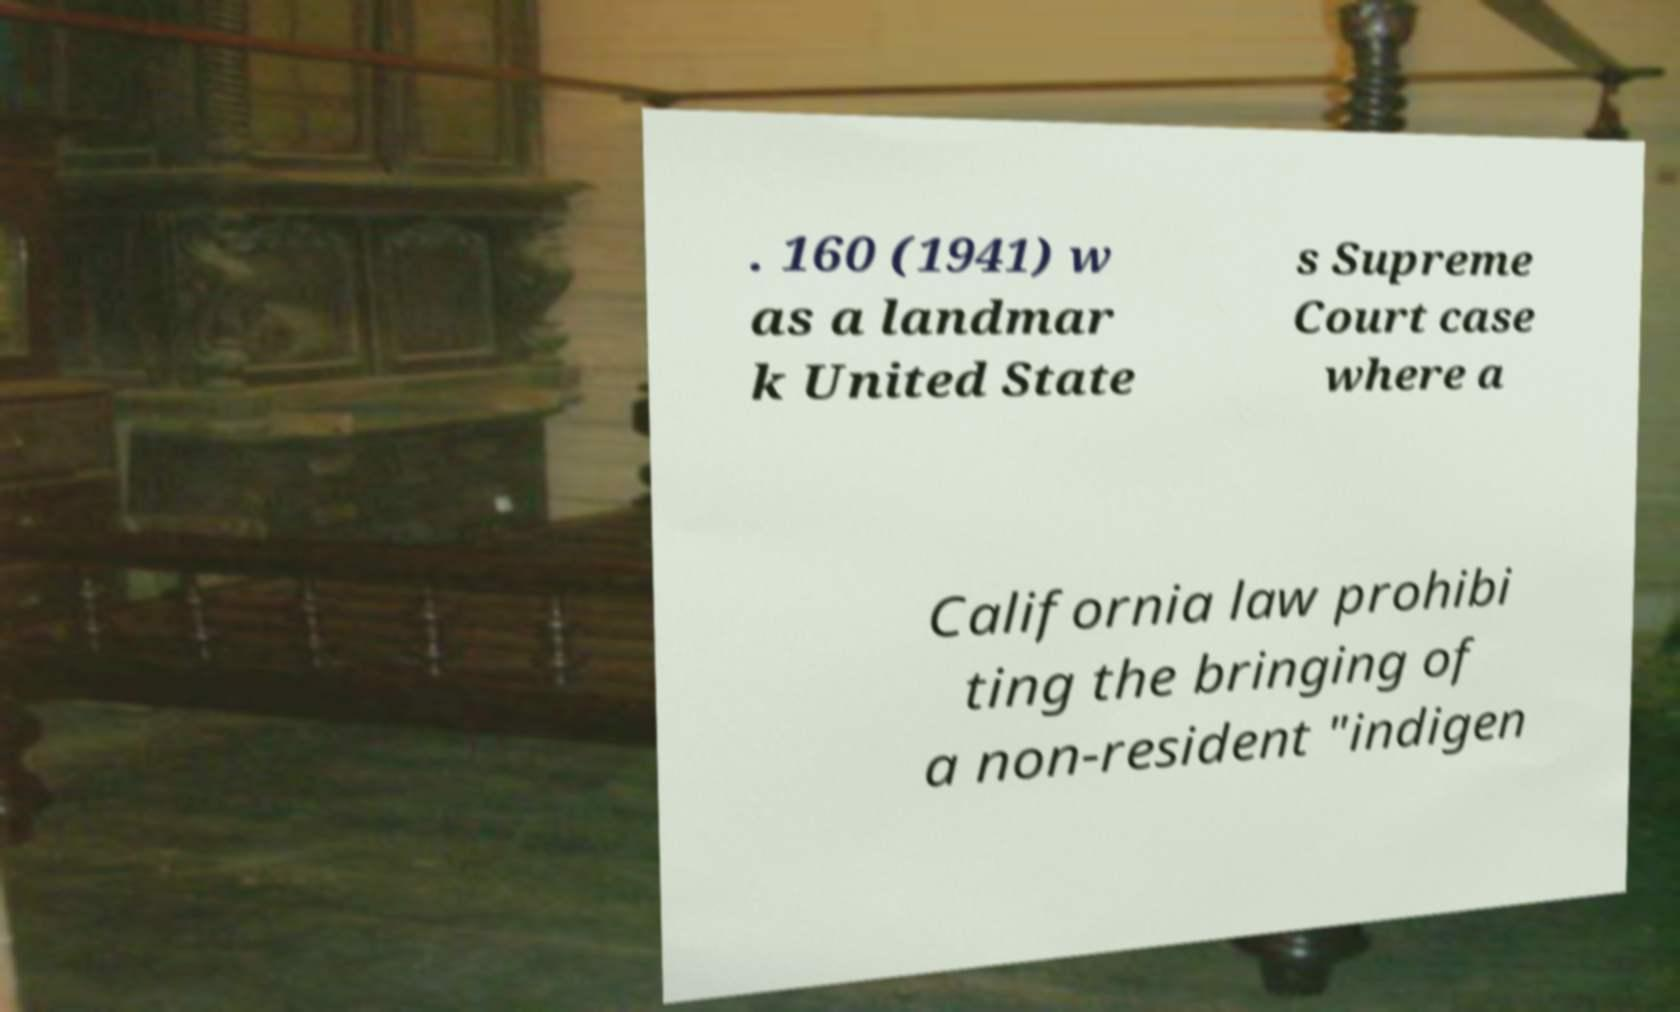For documentation purposes, I need the text within this image transcribed. Could you provide that? . 160 (1941) w as a landmar k United State s Supreme Court case where a California law prohibi ting the bringing of a non-resident "indigen 